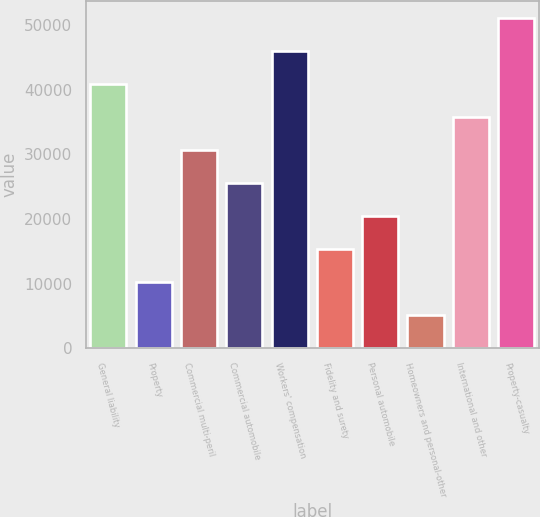Convert chart. <chart><loc_0><loc_0><loc_500><loc_500><bar_chart><fcel>General liability<fcel>Property<fcel>Commercial multi-peril<fcel>Commercial automobile<fcel>Workers' compensation<fcel>Fidelity and surety<fcel>Personal automobile<fcel>Homeowners and personal-other<fcel>International and other<fcel>Property-casualty<nl><fcel>40918.6<fcel>10281.4<fcel>30706.2<fcel>25600<fcel>46024.8<fcel>15387.6<fcel>20493.8<fcel>5175.2<fcel>35812.4<fcel>51131<nl></chart> 